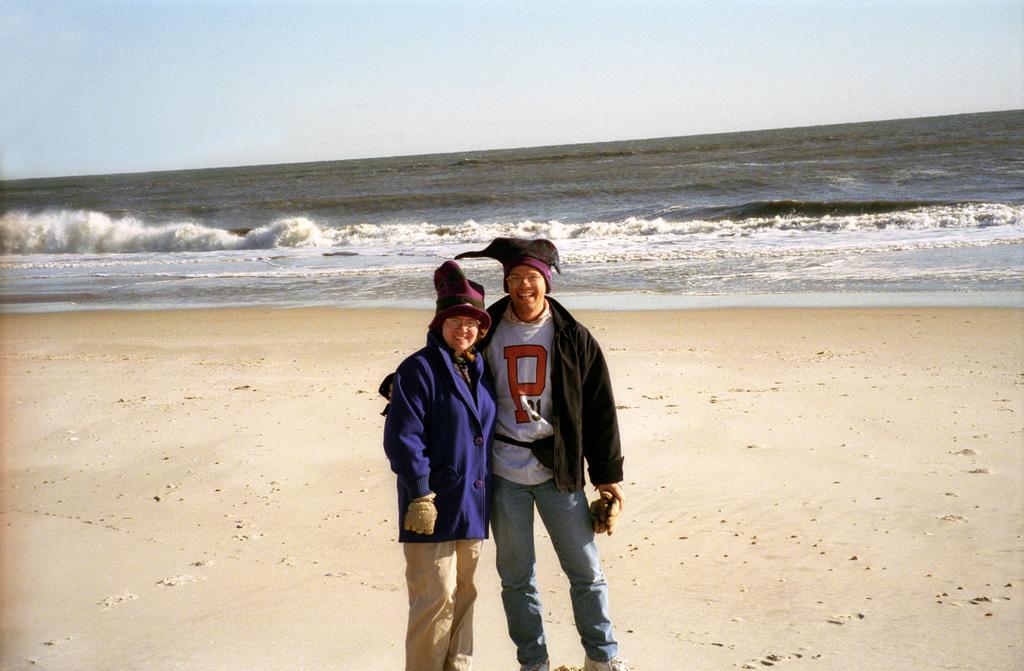How would you summarize this image in a sentence or two? In this image, we can see people standing and are wearing coats, caps and one of them is wearing glove and the other is holding gloves. In the background, there is water and at the bottom, there is sand. 